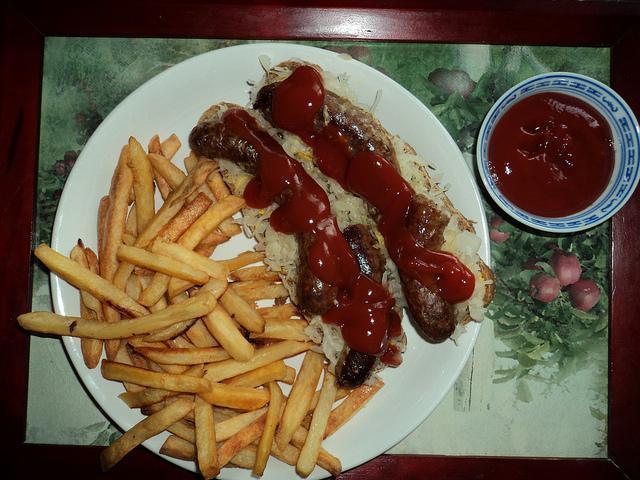What is the red sauce that is covering the hot dog sausages?
Choose the right answer from the provided options to respond to the question.
Options: Oyster, ketchup, hoisen, hot sauce. Ketchup. 